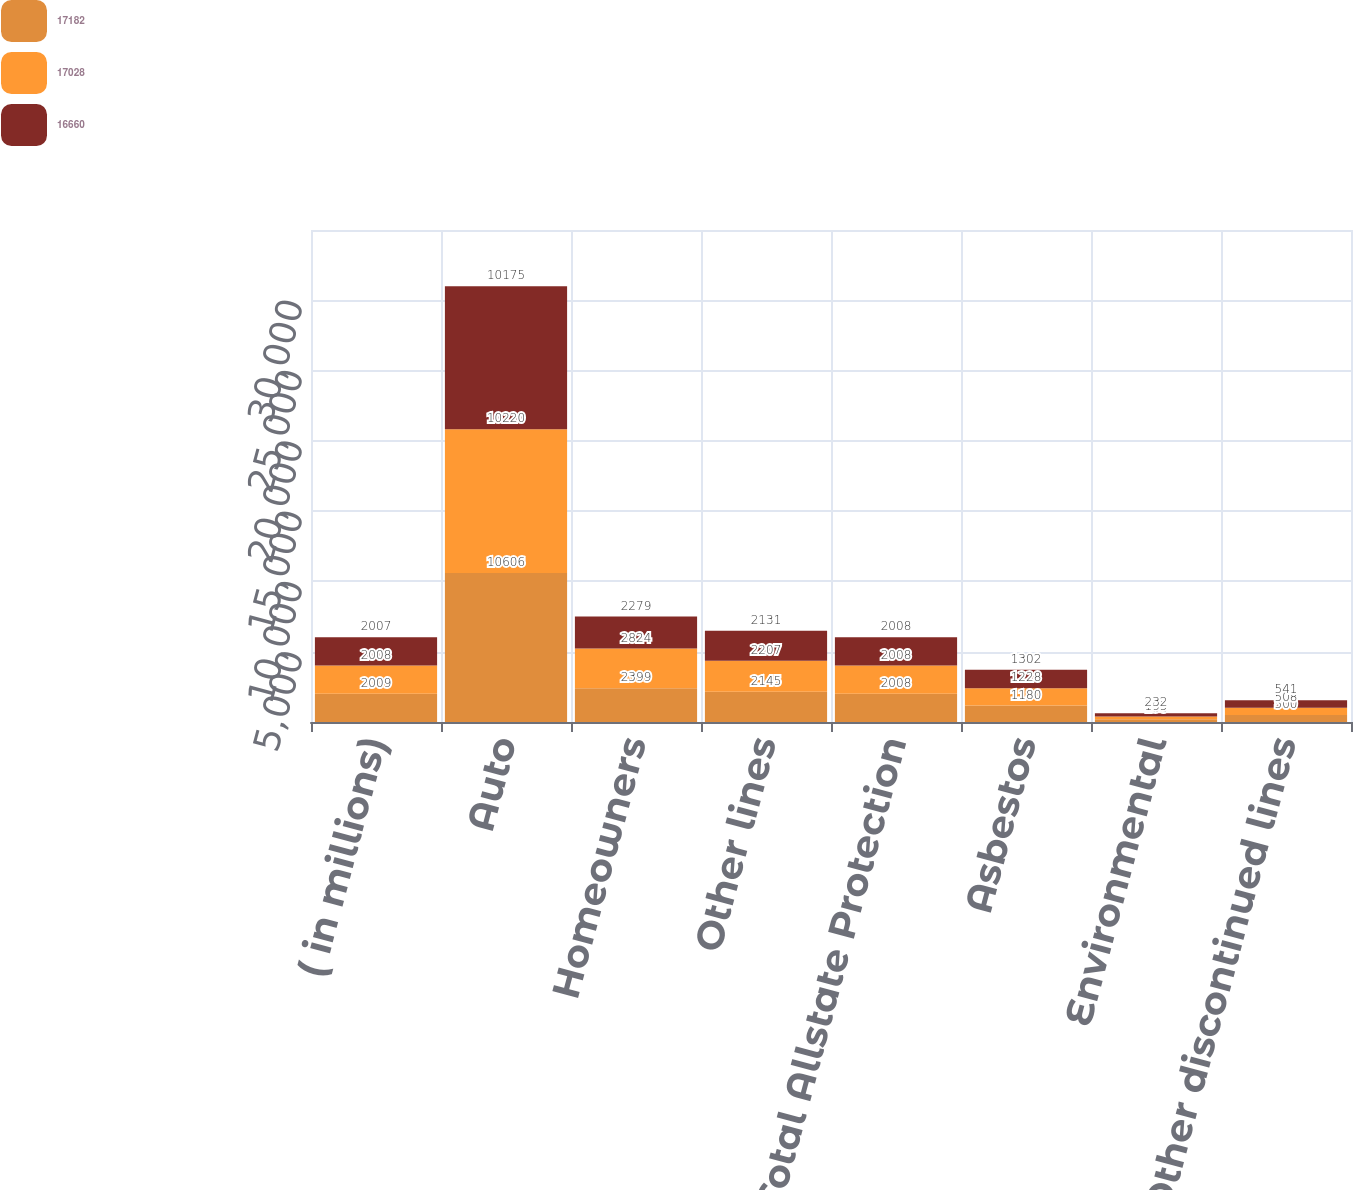Convert chart. <chart><loc_0><loc_0><loc_500><loc_500><stacked_bar_chart><ecel><fcel>( in millions)<fcel>Auto<fcel>Homeowners<fcel>Other lines<fcel>Total Allstate Protection<fcel>Asbestos<fcel>Environmental<fcel>Other discontinued lines<nl><fcel>17182<fcel>2009<fcel>10606<fcel>2399<fcel>2145<fcel>2008<fcel>1180<fcel>198<fcel>500<nl><fcel>17028<fcel>2008<fcel>10220<fcel>2824<fcel>2207<fcel>2008<fcel>1228<fcel>195<fcel>508<nl><fcel>16660<fcel>2007<fcel>10175<fcel>2279<fcel>2131<fcel>2008<fcel>1302<fcel>232<fcel>541<nl></chart> 